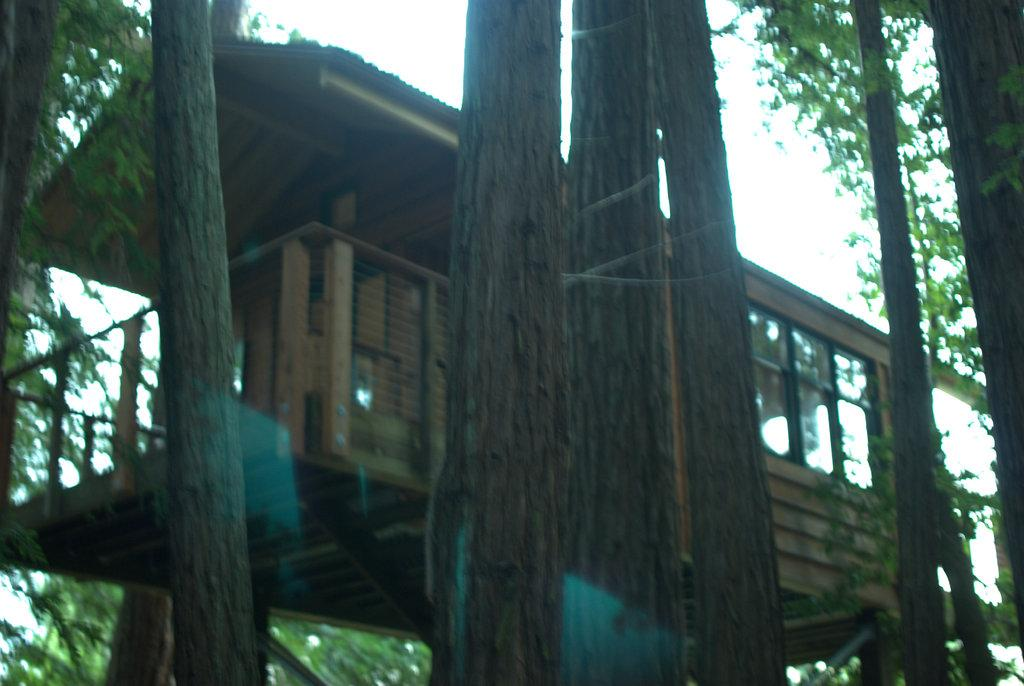What type of natural elements are present in the image? There are many trees in the image. Can you describe any structures built on the trees? Yes, there is a tree house in the image. What can be seen in the background of the image? The sky is visible in the background of the image. What time of day is it in the image, as indicated by the hour on the clock tower? There is no clock tower present in the image, so it is not possible to determine the hour. 